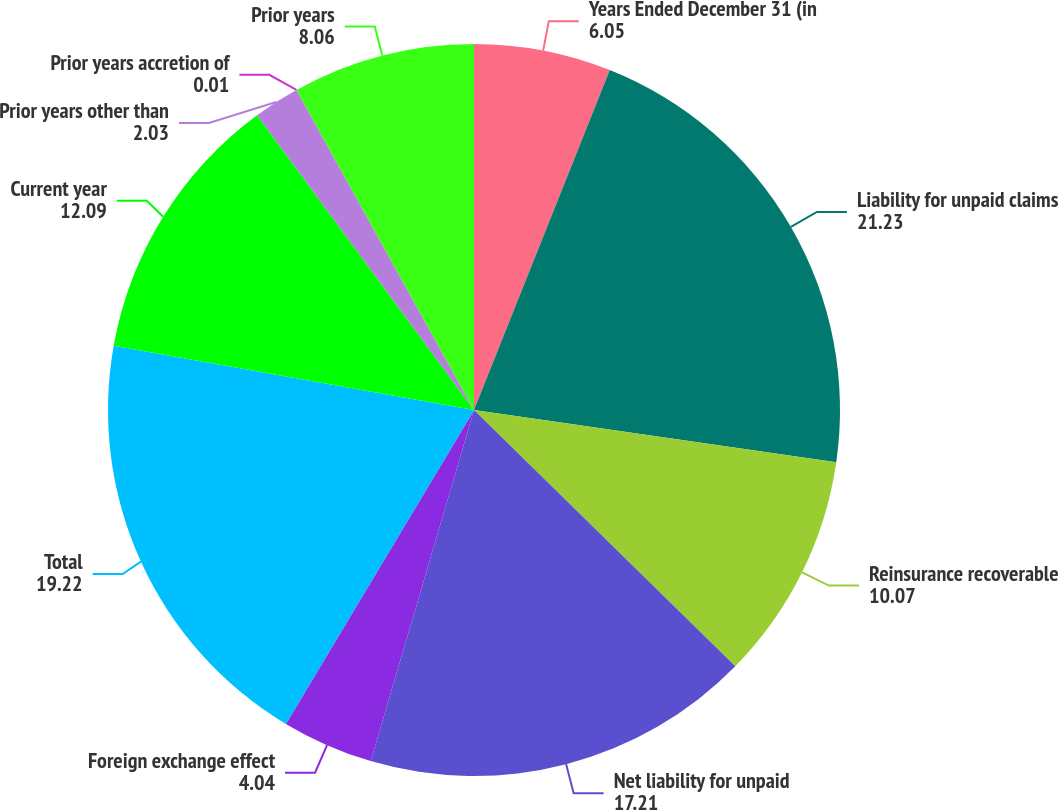Convert chart to OTSL. <chart><loc_0><loc_0><loc_500><loc_500><pie_chart><fcel>Years Ended December 31 (in<fcel>Liability for unpaid claims<fcel>Reinsurance recoverable<fcel>Net liability for unpaid<fcel>Foreign exchange effect<fcel>Total<fcel>Current year<fcel>Prior years other than<fcel>Prior years accretion of<fcel>Prior years<nl><fcel>6.05%<fcel>21.23%<fcel>10.07%<fcel>17.21%<fcel>4.04%<fcel>19.22%<fcel>12.09%<fcel>2.03%<fcel>0.01%<fcel>8.06%<nl></chart> 